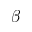<formula> <loc_0><loc_0><loc_500><loc_500>\beta</formula> 